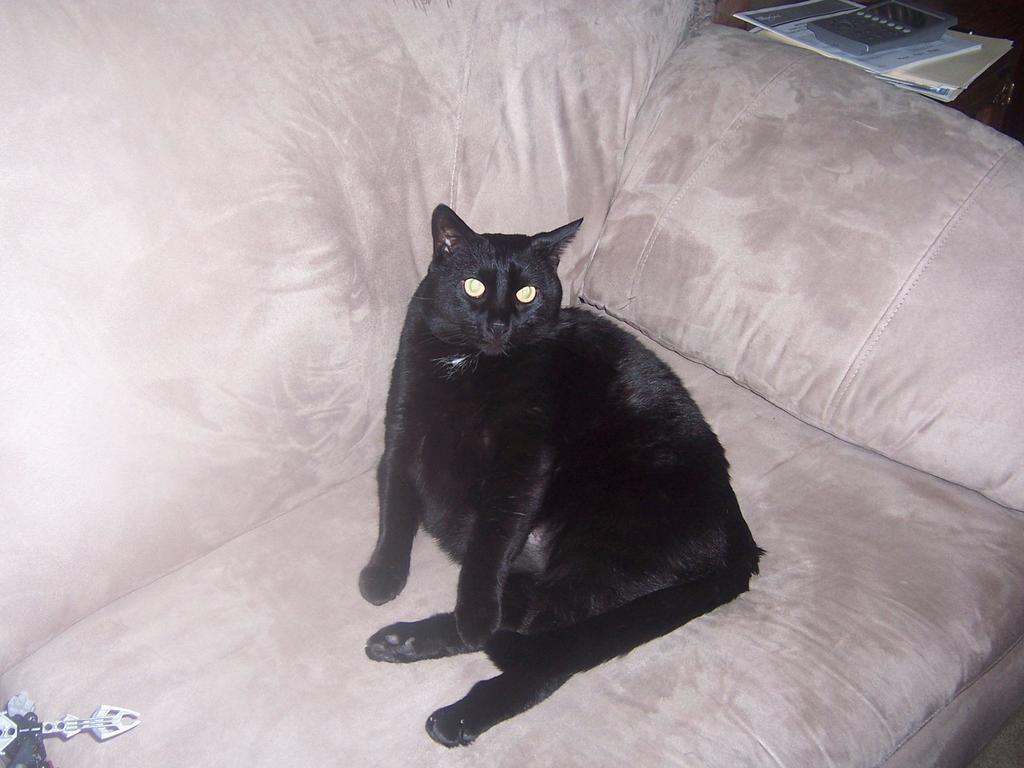Can you describe this image briefly? In this image I can see a cat which is black in color is laying on a couch which is cream in color. I can see an object on the couch and to the right top of the image I can see few books and a calculator. 